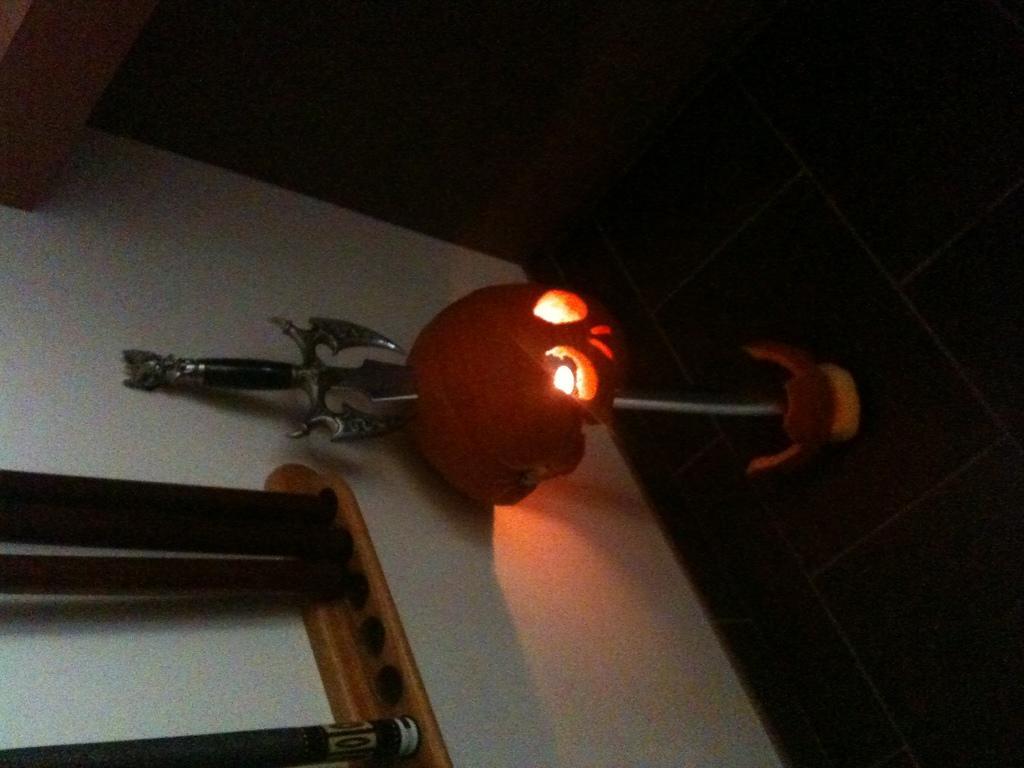Could you give a brief overview of what you see in this image? In this image I can see few lights and a weapon, background I can see few wooden objects and the wall is in white color. 